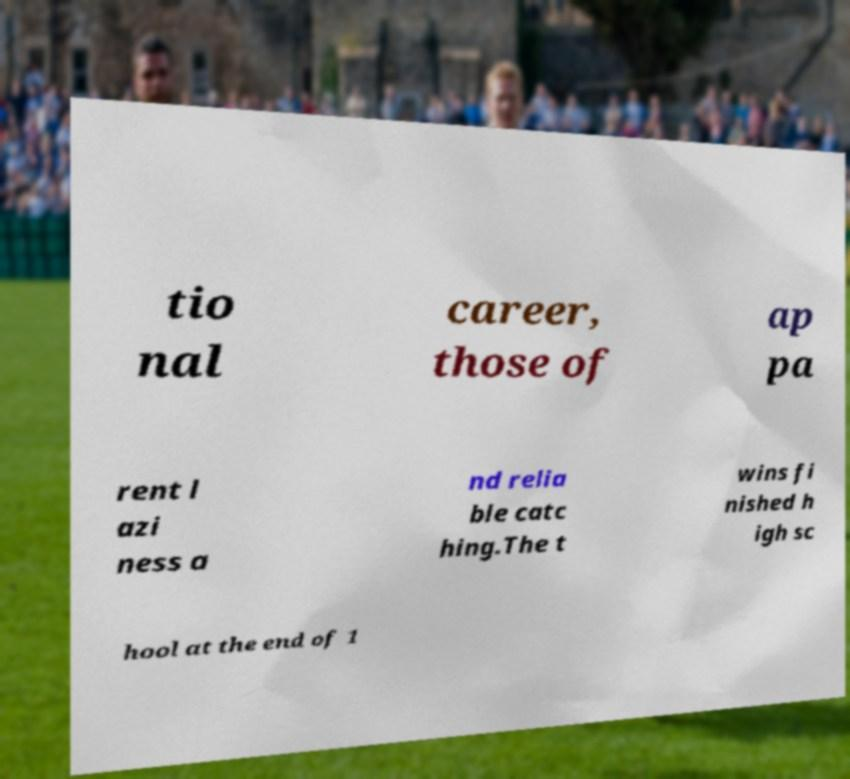Could you extract and type out the text from this image? tio nal career, those of ap pa rent l azi ness a nd relia ble catc hing.The t wins fi nished h igh sc hool at the end of 1 